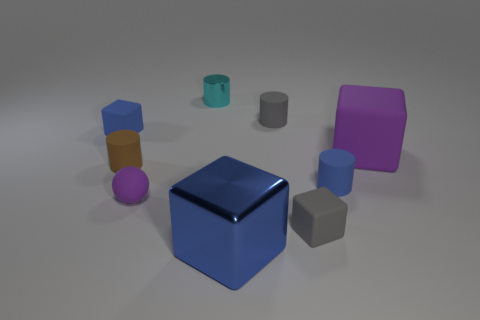Add 1 tiny cyan objects. How many objects exist? 10 Subtract all gray cylinders. How many cylinders are left? 3 Subtract all tiny blue cylinders. How many cylinders are left? 3 Subtract all cylinders. How many objects are left? 5 Subtract all tiny cyan shiny blocks. Subtract all brown matte cylinders. How many objects are left? 8 Add 3 matte cubes. How many matte cubes are left? 6 Add 5 tiny gray matte cubes. How many tiny gray matte cubes exist? 6 Subtract 1 gray cylinders. How many objects are left? 8 Subtract 4 blocks. How many blocks are left? 0 Subtract all red spheres. Subtract all yellow cylinders. How many spheres are left? 1 